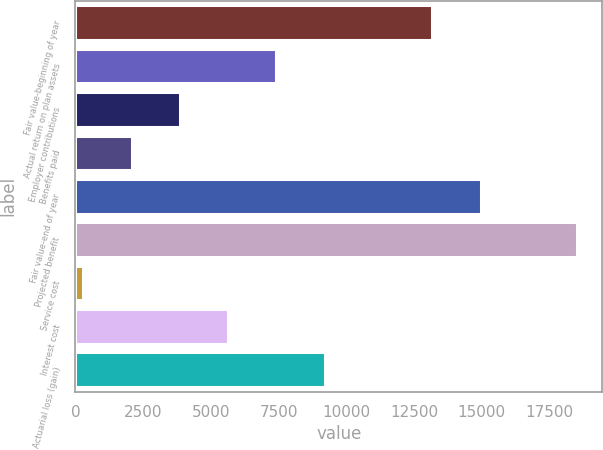Convert chart. <chart><loc_0><loc_0><loc_500><loc_500><bar_chart><fcel>Fair value-beginning of year<fcel>Actual return on plan assets<fcel>Employer contributions<fcel>Benefits paid<fcel>Fair value-end of year<fcel>Projected benefit<fcel>Service cost<fcel>Interest cost<fcel>Actuarial loss (gain)<nl><fcel>13180<fcel>7415.2<fcel>3854.6<fcel>2074.3<fcel>14960.3<fcel>18520.9<fcel>294<fcel>5634.9<fcel>9195.5<nl></chart> 